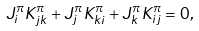<formula> <loc_0><loc_0><loc_500><loc_500>J ^ { \pi } _ { i } K ^ { \pi } _ { j k } + J ^ { \pi } _ { j } K ^ { \pi } _ { k i } + J ^ { \pi } _ { k } K ^ { \pi } _ { i j } = 0 ,</formula> 